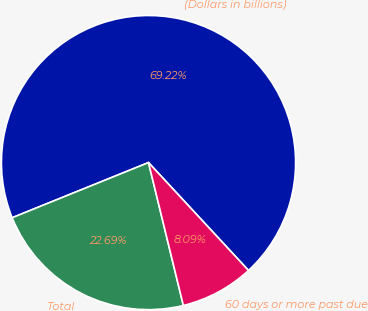Convert chart. <chart><loc_0><loc_0><loc_500><loc_500><pie_chart><fcel>(Dollars in billions)<fcel>Total<fcel>60 days or more past due<nl><fcel>69.23%<fcel>22.69%<fcel>8.09%<nl></chart> 